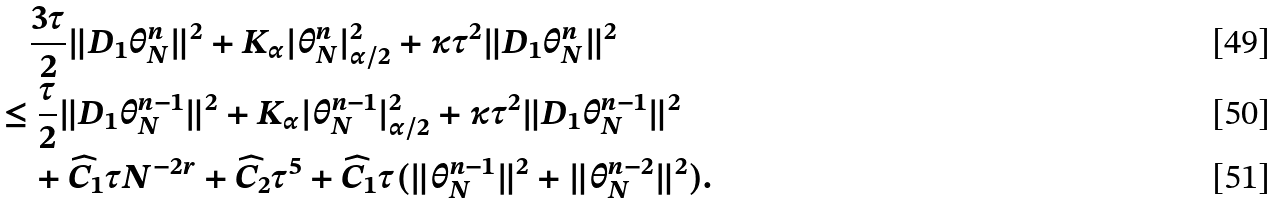Convert formula to latex. <formula><loc_0><loc_0><loc_500><loc_500>& \quad \frac { 3 \tau } { 2 } \| D _ { 1 } \theta _ { N } ^ { n } \| ^ { 2 } + { K _ { \alpha } } | \theta _ { N } ^ { n } | ^ { 2 } _ { \alpha / 2 } + \kappa \tau ^ { 2 } \| D _ { 1 } \theta _ { N } ^ { n } \| ^ { 2 } \\ & \leq \frac { \tau } { 2 } \| D _ { 1 } \theta ^ { n - 1 } _ { N } \| ^ { 2 } + K _ { \alpha } | \theta ^ { n - 1 } _ { N } | _ { \alpha / 2 } ^ { 2 } + \kappa \tau ^ { 2 } \| D _ { 1 } \theta _ { N } ^ { n - 1 } \| ^ { 2 } \\ & \quad + \widehat { C } _ { 1 } \tau N ^ { - 2 r } + \widehat { C } _ { 2 } \tau ^ { 5 } + \widehat { C } _ { 1 } \tau ( \| \theta _ { N } ^ { n - 1 } \| ^ { 2 } + \| \theta _ { N } ^ { n - 2 } \| ^ { 2 } ) .</formula> 